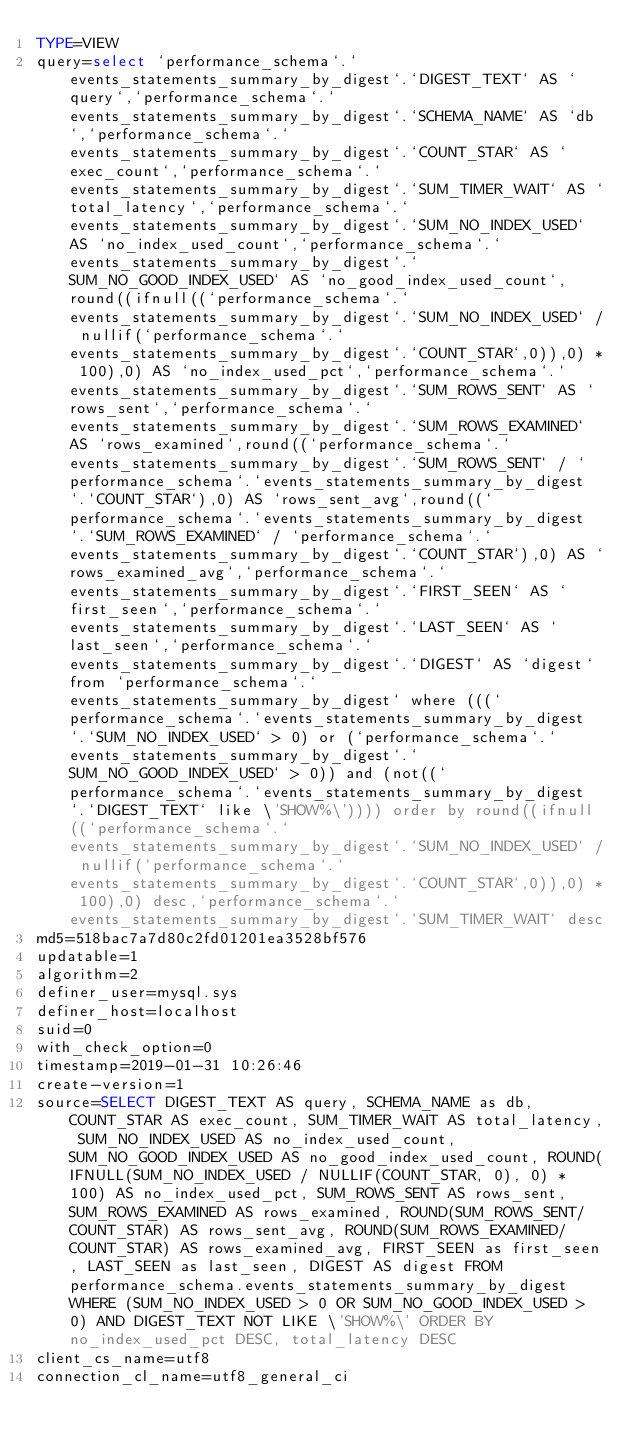Convert code to text. <code><loc_0><loc_0><loc_500><loc_500><_VisualBasic_>TYPE=VIEW
query=select `performance_schema`.`events_statements_summary_by_digest`.`DIGEST_TEXT` AS `query`,`performance_schema`.`events_statements_summary_by_digest`.`SCHEMA_NAME` AS `db`,`performance_schema`.`events_statements_summary_by_digest`.`COUNT_STAR` AS `exec_count`,`performance_schema`.`events_statements_summary_by_digest`.`SUM_TIMER_WAIT` AS `total_latency`,`performance_schema`.`events_statements_summary_by_digest`.`SUM_NO_INDEX_USED` AS `no_index_used_count`,`performance_schema`.`events_statements_summary_by_digest`.`SUM_NO_GOOD_INDEX_USED` AS `no_good_index_used_count`,round((ifnull((`performance_schema`.`events_statements_summary_by_digest`.`SUM_NO_INDEX_USED` / nullif(`performance_schema`.`events_statements_summary_by_digest`.`COUNT_STAR`,0)),0) * 100),0) AS `no_index_used_pct`,`performance_schema`.`events_statements_summary_by_digest`.`SUM_ROWS_SENT` AS `rows_sent`,`performance_schema`.`events_statements_summary_by_digest`.`SUM_ROWS_EXAMINED` AS `rows_examined`,round((`performance_schema`.`events_statements_summary_by_digest`.`SUM_ROWS_SENT` / `performance_schema`.`events_statements_summary_by_digest`.`COUNT_STAR`),0) AS `rows_sent_avg`,round((`performance_schema`.`events_statements_summary_by_digest`.`SUM_ROWS_EXAMINED` / `performance_schema`.`events_statements_summary_by_digest`.`COUNT_STAR`),0) AS `rows_examined_avg`,`performance_schema`.`events_statements_summary_by_digest`.`FIRST_SEEN` AS `first_seen`,`performance_schema`.`events_statements_summary_by_digest`.`LAST_SEEN` AS `last_seen`,`performance_schema`.`events_statements_summary_by_digest`.`DIGEST` AS `digest` from `performance_schema`.`events_statements_summary_by_digest` where (((`performance_schema`.`events_statements_summary_by_digest`.`SUM_NO_INDEX_USED` > 0) or (`performance_schema`.`events_statements_summary_by_digest`.`SUM_NO_GOOD_INDEX_USED` > 0)) and (not((`performance_schema`.`events_statements_summary_by_digest`.`DIGEST_TEXT` like \'SHOW%\')))) order by round((ifnull((`performance_schema`.`events_statements_summary_by_digest`.`SUM_NO_INDEX_USED` / nullif(`performance_schema`.`events_statements_summary_by_digest`.`COUNT_STAR`,0)),0) * 100),0) desc,`performance_schema`.`events_statements_summary_by_digest`.`SUM_TIMER_WAIT` desc
md5=518bac7a7d80c2fd01201ea3528bf576
updatable=1
algorithm=2
definer_user=mysql.sys
definer_host=localhost
suid=0
with_check_option=0
timestamp=2019-01-31 10:26:46
create-version=1
source=SELECT DIGEST_TEXT AS query, SCHEMA_NAME as db, COUNT_STAR AS exec_count, SUM_TIMER_WAIT AS total_latency, SUM_NO_INDEX_USED AS no_index_used_count, SUM_NO_GOOD_INDEX_USED AS no_good_index_used_count, ROUND(IFNULL(SUM_NO_INDEX_USED / NULLIF(COUNT_STAR, 0), 0) * 100) AS no_index_used_pct, SUM_ROWS_SENT AS rows_sent, SUM_ROWS_EXAMINED AS rows_examined, ROUND(SUM_ROWS_SENT/COUNT_STAR) AS rows_sent_avg, ROUND(SUM_ROWS_EXAMINED/COUNT_STAR) AS rows_examined_avg, FIRST_SEEN as first_seen, LAST_SEEN as last_seen, DIGEST AS digest FROM performance_schema.events_statements_summary_by_digest WHERE (SUM_NO_INDEX_USED > 0 OR SUM_NO_GOOD_INDEX_USED > 0) AND DIGEST_TEXT NOT LIKE \'SHOW%\' ORDER BY no_index_used_pct DESC, total_latency DESC
client_cs_name=utf8
connection_cl_name=utf8_general_ci</code> 